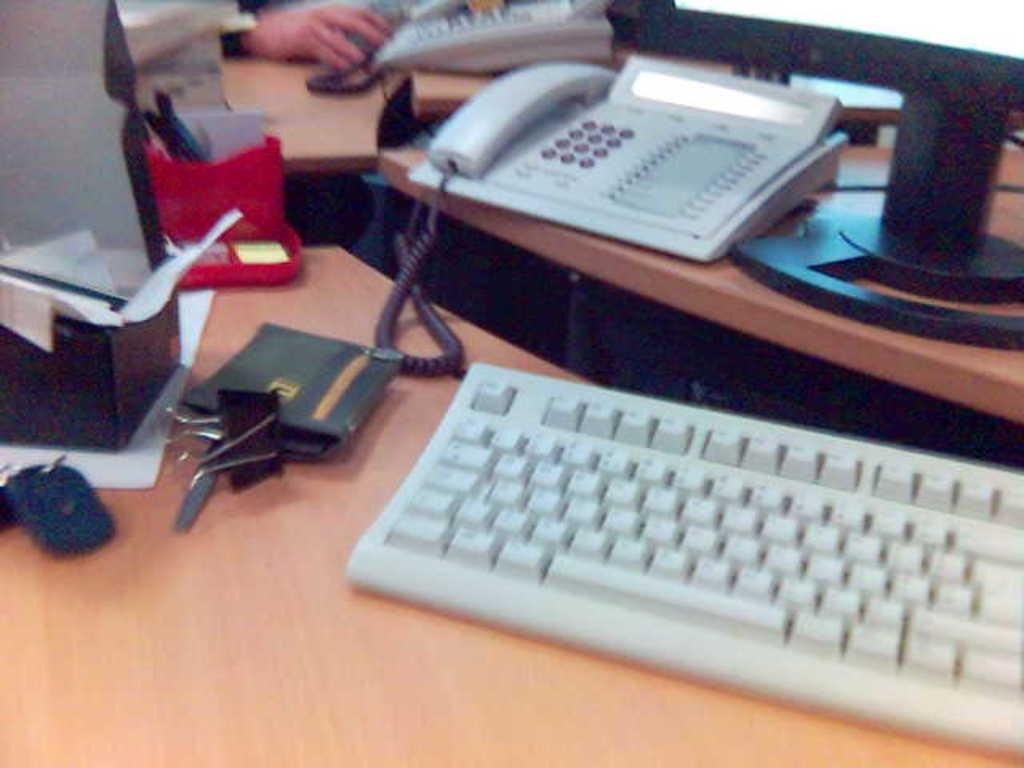What type of device is present in the image? There is a keyboard in the image. What personal item can be seen in the image? There is a purse in the image. What type of stationery items are visible in the image? There are papers and pens in the image. What communication device is present in the image? There is a telephone in the image. Whose hand is visible in the image? A human hand is visible in the image. What surface are all these objects placed on? All these objects are on a table. How many pets are visible in the image? There are no pets present in the image. What type of voice can be heard coming from the cellar in the image? There is no cellar or voice present in the image. 